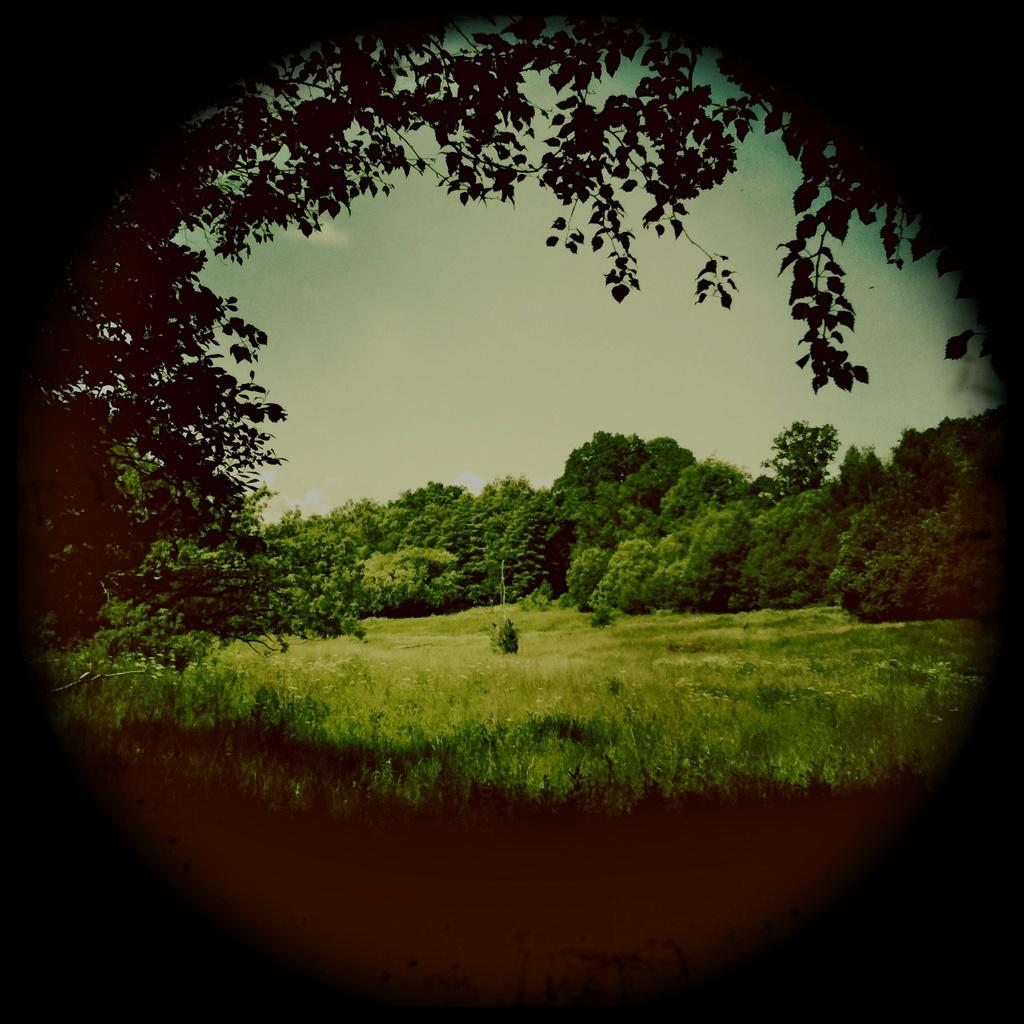What type of landscape is depicted in the image? There is a grassland in the image. What can be seen in the distance in the image? There are trees in the background of the image. What is visible above the grassland and trees in the image? The sky is visible in the background of the image. What type of crib is visible in the image? There is no crib present in the image; it features a grassland, trees, and the sky. Is there a veil covering the grassland in the image? No, there is no veil present in the image; the grassland is visible without any covering. 